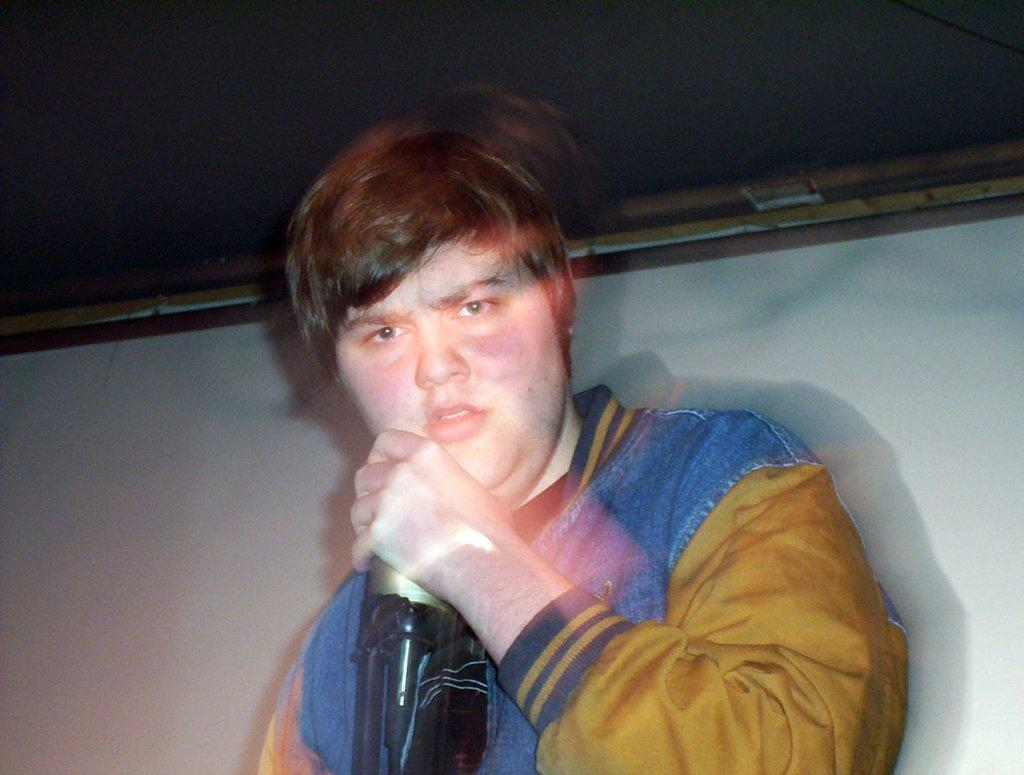What is the main subject of the image? The main subject of the image is a boy. What is the boy holding in his hand? The boy is holding a bottle in his hand. What can be seen in the background of the image? There is a wall in the background of the image. Can you see a frog jumping on the wall in the image? There is no frog visible in the image, and no indication of any jumping activity. 